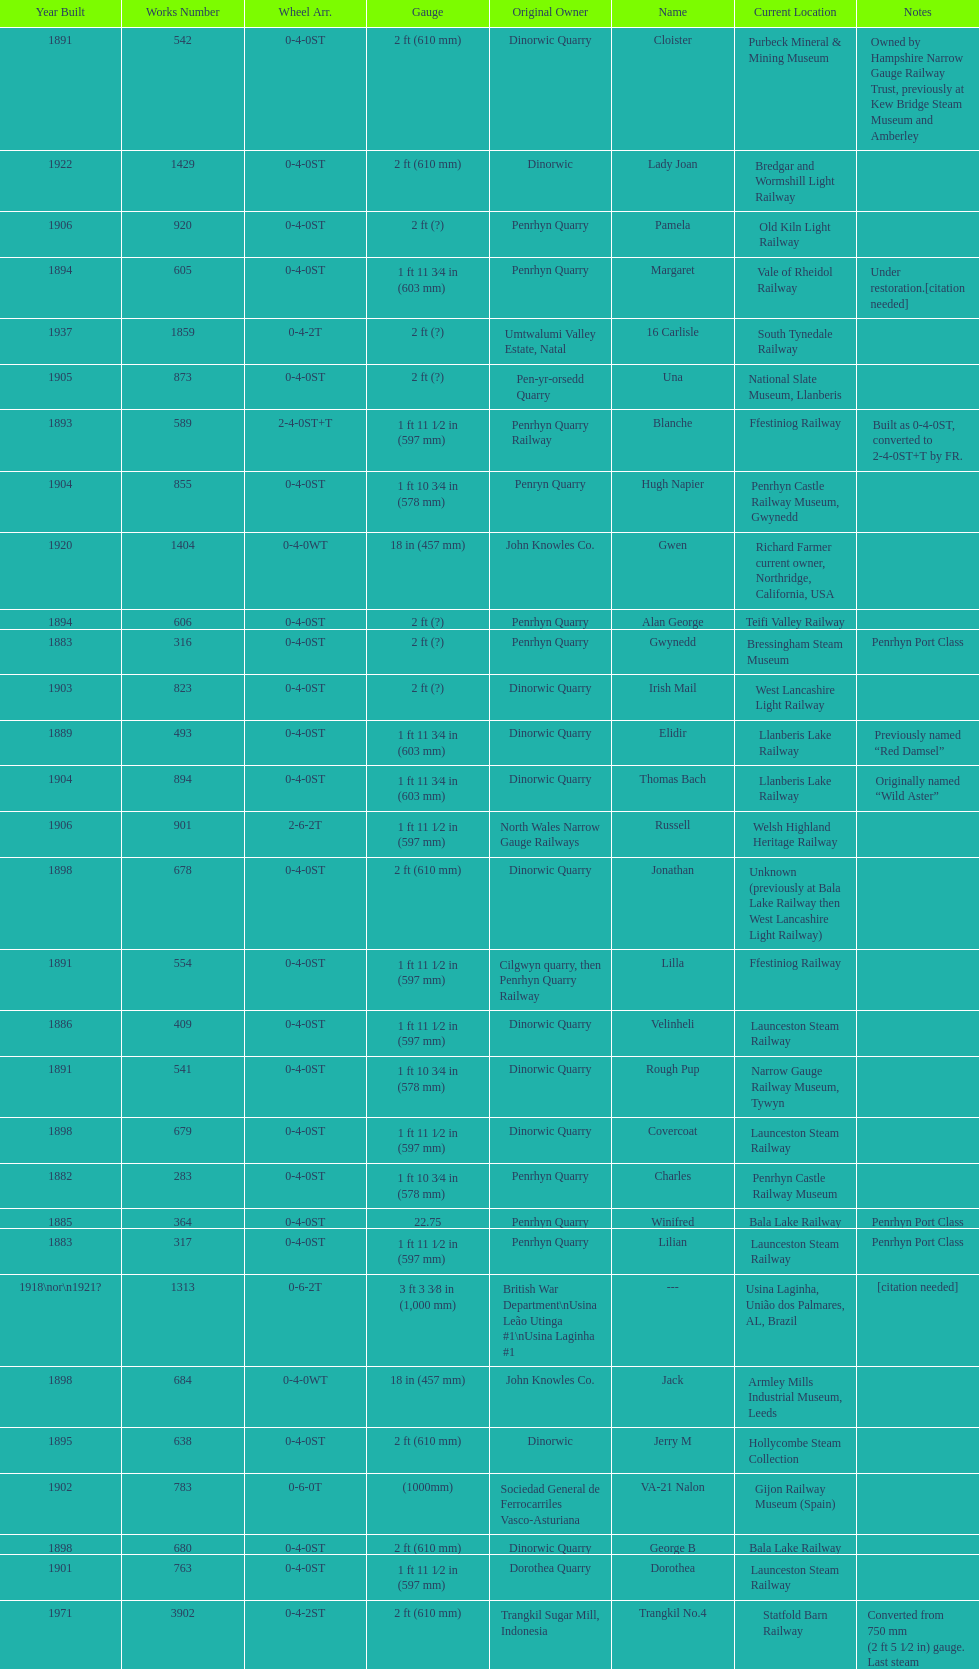Which works number had a larger gauge, 283 or 317? 317. 